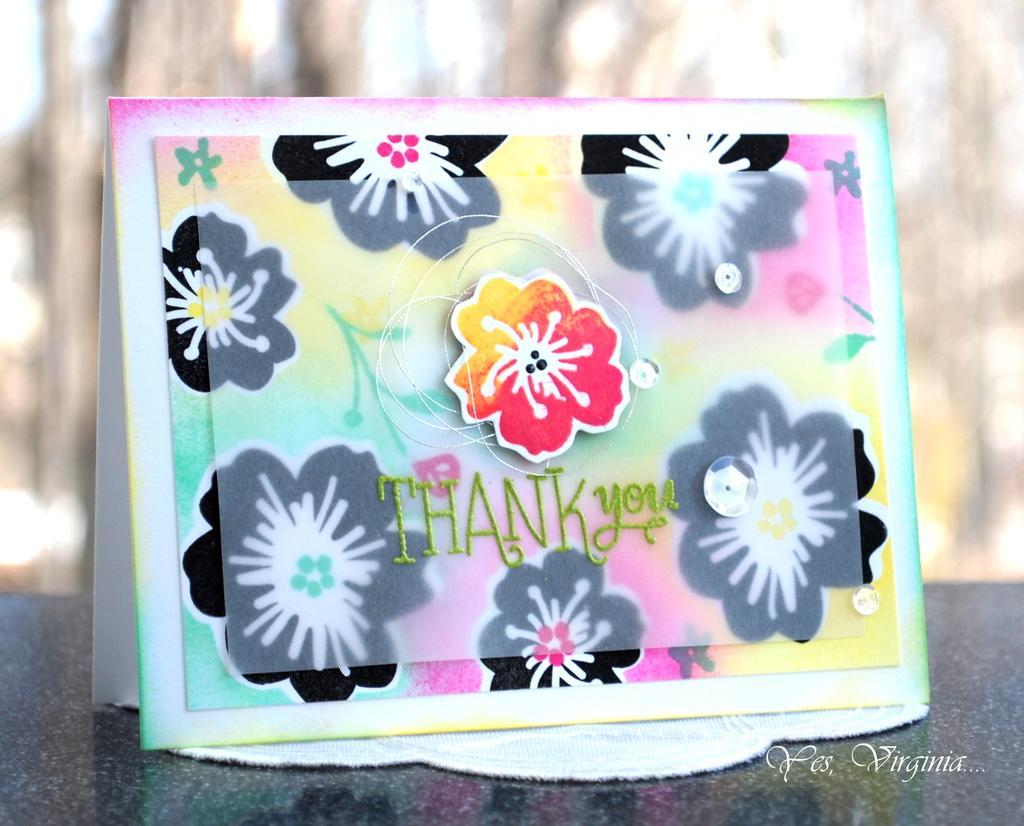Please provide a concise description of this image. In this image there is a thank you card on a table. The background is blurry. 